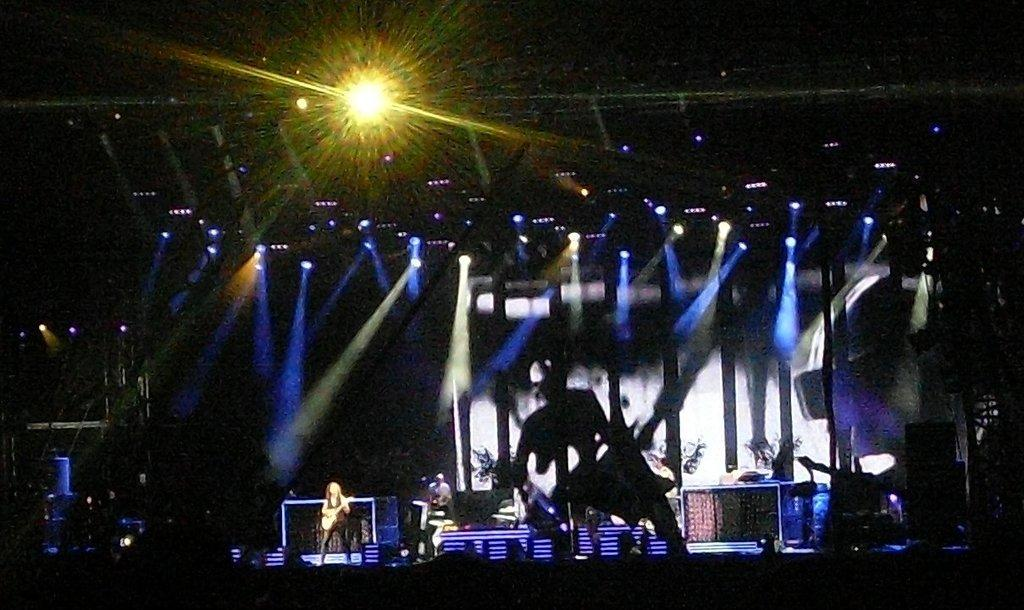What is the color of the background in the image? The background of the image is dark. Can you describe the people in the background? There are people in the background of the image. What is the person among the people doing? There is a person playing a guitar among the people. What can be seen in the image besides the people? Lights and objects are visible in the image. What type of berry is being used to make a statement in the image? There is no berry present in the image, nor is there any indication of someone making a statement. 